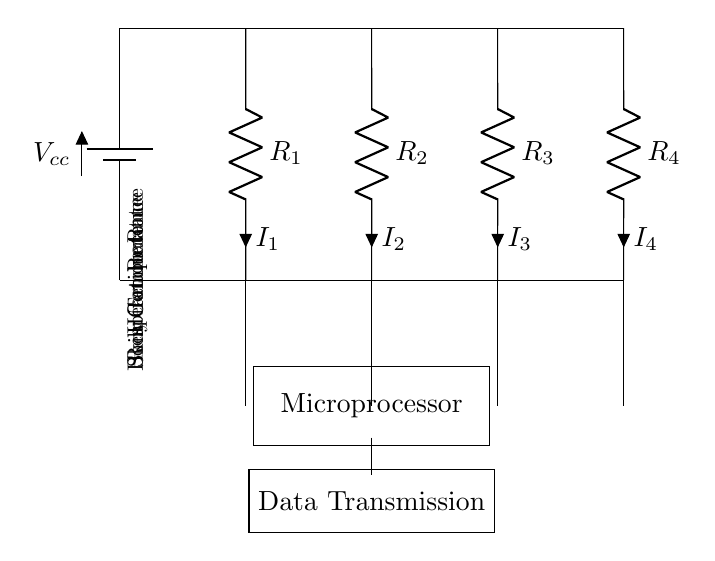What components are in the circuit? The circuit contains four resistors representing different stress indicators: heart rate, skin conductance, respiration rate, and body temperature. Each component is labeled R1, R2, R3, and R4, showing the specific stress indicators it measures.
Answer: Resistors for heart rate, skin conductance, respiration rate, body temperature What is the function of the microprocessor in this circuit? The microprocessor serves as the central processing unit where the data from the resistors is collected, processed, and transmitted for further analysis or display, acting as the brain of the wearable device.
Answer: Data processing How many pathways are present in this circuit? The circuit is arranged in a parallel configuration, meaning there are multiple pathways for current to flow through each resistor independently. Since there are four resistors, there are four separate current pathways.
Answer: Four If R1 has a current of 0.5A, what can be inferred about the other resistors? In a parallel circuit, the voltage across all components is the same. While R1 has a current of 0.5A, each of the other resistors (R2, R3, R4) can have different currents flowing through them, but they're all subject to the same supply voltage, indicating that their individual currents will depend on their resistance values as per Ohm's Law.
Answer: Same voltage across resistors Why is the circuit designed in parallel rather than series? A parallel circuit allows for individual components (resistors) to operate independently. If one resistor fails, the others can still function, ensuring the wearable device can measure multiple stress indicators simultaneously without interruption, which is essential for real-time monitoring.
Answer: Independent operation What is the purpose of the data transmission section? The data transmission section is responsible for sending processed data to another device or platform, enabling the user to view the stress indicators in real-time, which is crucial for monitoring overall well-being.
Answer: Send data to display 